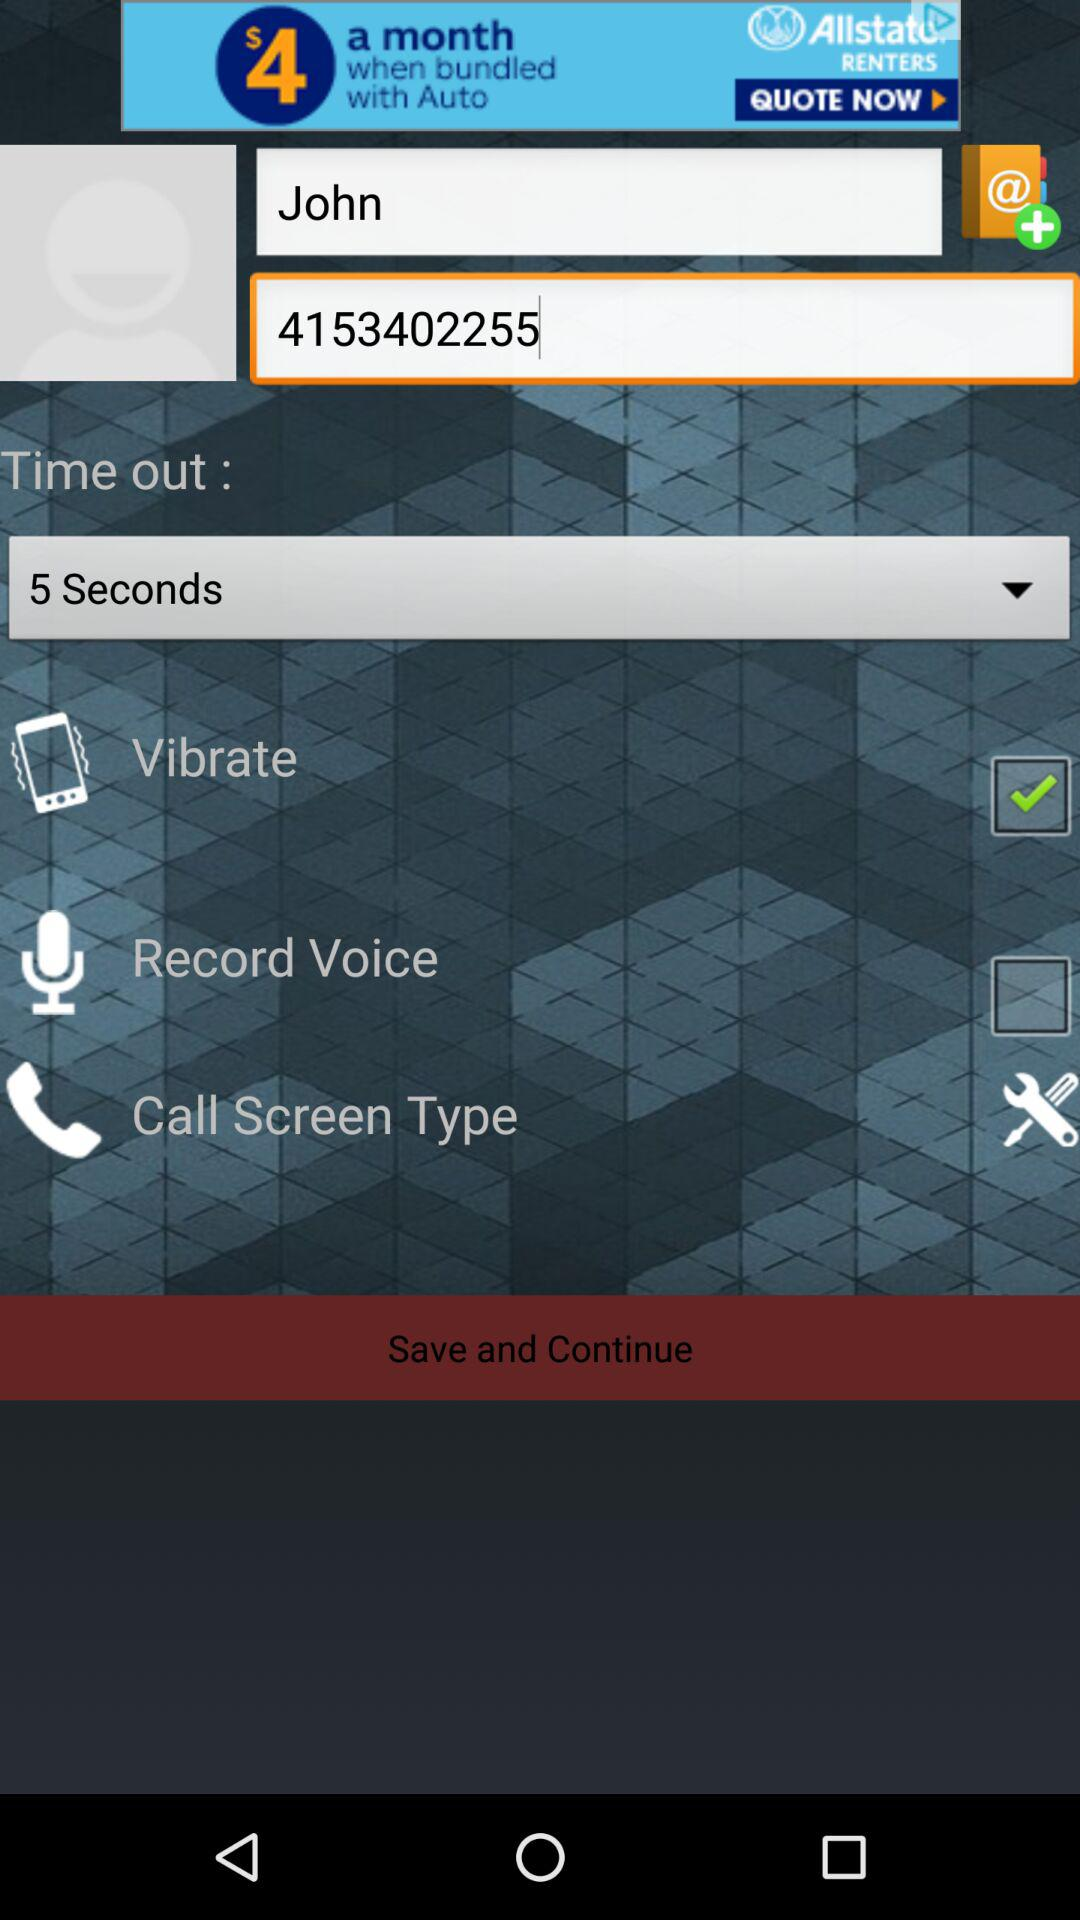What are all the time out options?
When the provided information is insufficient, respond with <no answer>. <no answer> 